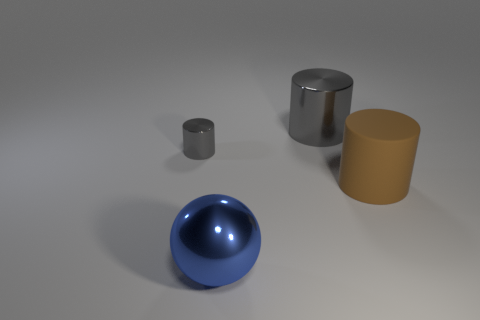What number of large cylinders have the same color as the tiny metallic object?
Provide a short and direct response. 1. Is the color of the metal cylinder that is to the left of the blue shiny object the same as the large metallic cylinder?
Your answer should be compact. Yes. There is a object that is on the right side of the small gray thing and behind the brown cylinder; what material is it made of?
Keep it short and to the point. Metal. Is there a big rubber object left of the rubber cylinder that is right of the small gray metallic cylinder?
Your response must be concise. No. Are the small gray thing and the brown cylinder made of the same material?
Your response must be concise. No. What is the shape of the big thing that is both in front of the small gray shiny cylinder and on the right side of the blue shiny object?
Your answer should be very brief. Cylinder. How big is the gray cylinder that is on the left side of the thing in front of the brown thing?
Your response must be concise. Small. What number of big matte objects have the same shape as the tiny gray shiny object?
Offer a terse response. 1. Do the metal sphere and the rubber cylinder have the same color?
Keep it short and to the point. No. Are there any other things that are the same shape as the big blue shiny thing?
Keep it short and to the point. No. 